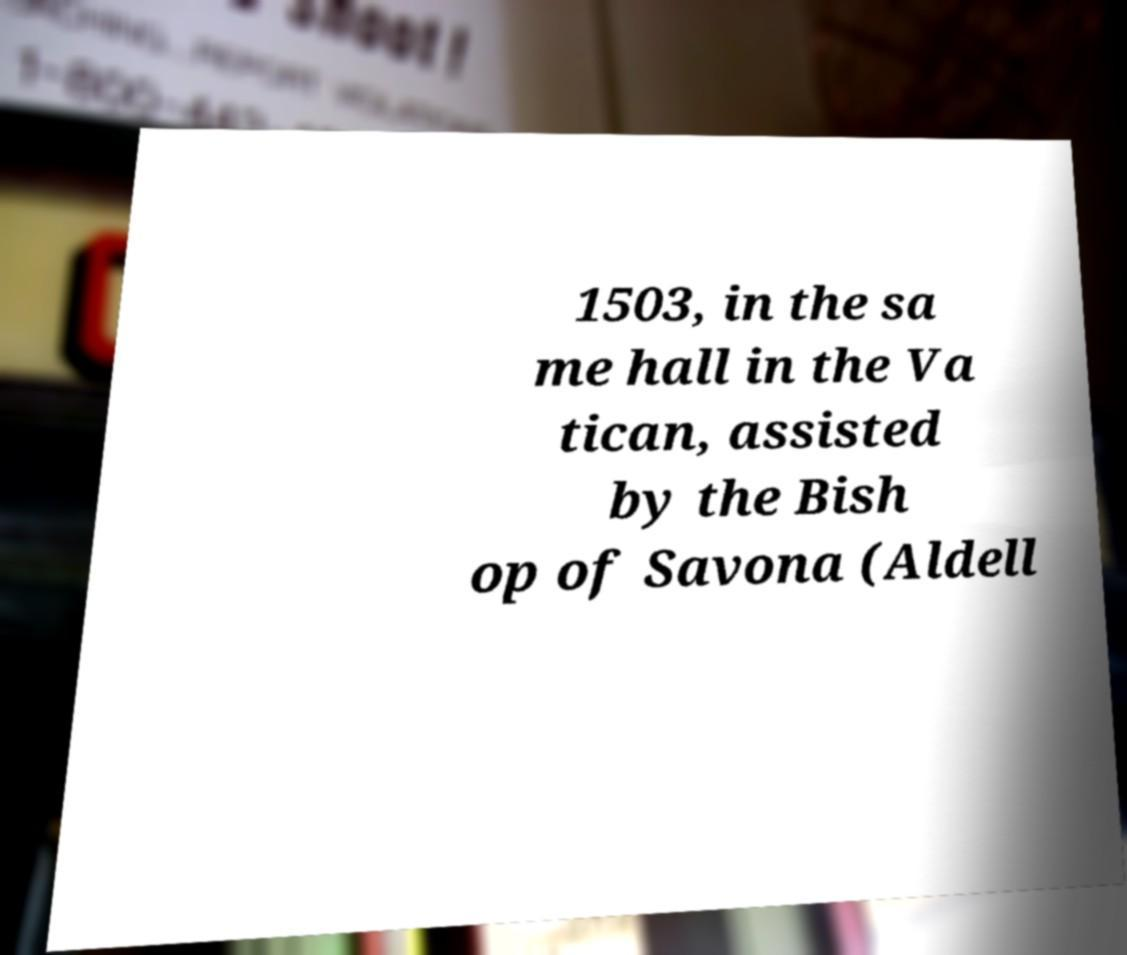Please identify and transcribe the text found in this image. 1503, in the sa me hall in the Va tican, assisted by the Bish op of Savona (Aldell 